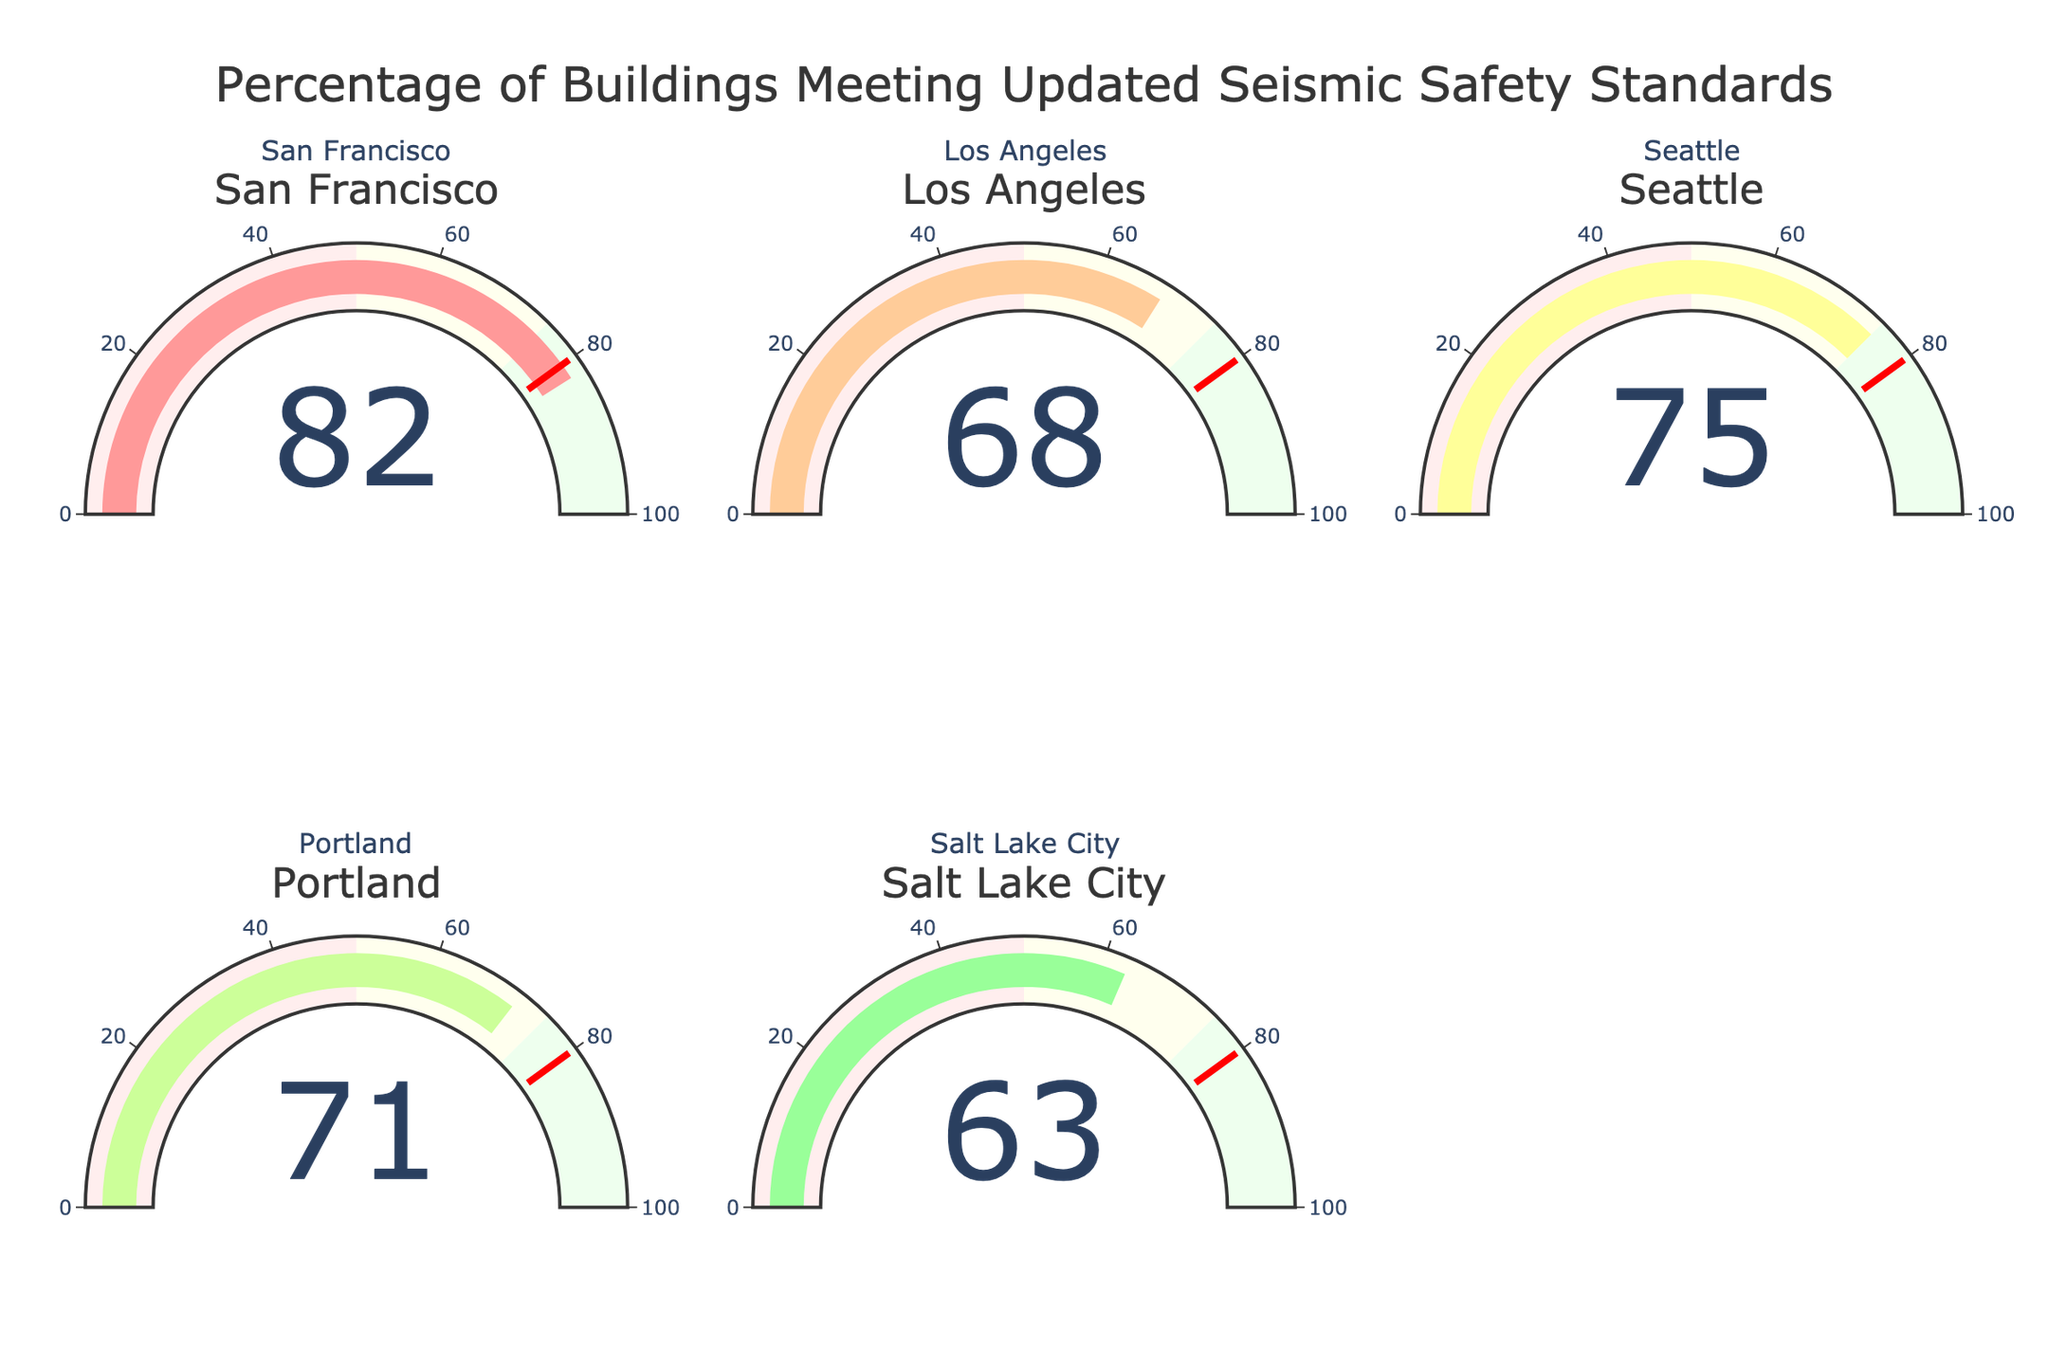What's the title of the chart? The title of the chart is displayed at the top center and reads "Percentage of Buildings Meeting Updated Seismic Safety Standards."
Answer: Percentage of Buildings Meeting Updated Seismic Safety Standards How many cities are represented in the chart? The chart has a total of 5 gauges, each representing a different city. This information can be observed by counting the number of individual gauge charts.
Answer: 5 Which city has the highest percentage of buildings meeting the updated seismic safety standards? The gauge showing the highest value is for San Francisco, which has 82%.
Answer: San Francisco Which city has the lowest percentage of buildings meeting the updated seismic safety standards? The gauge with the lowest value shows Salt Lake City with 63%.
Answer: Salt Lake City What's the average percentage of buildings meeting the updated seismic safety standards across all cities? Add the percentages for all cities (82 + 68 + 75 + 71 + 63) to get 359 and divide by the number of cities (5). The average is 359 / 5 = 71.8.
Answer: 71.8 What's the difference between the city with the highest percentage and the city with the lowest percentage? Subtract the lowest percentage (Salt Lake City, 63%) from the highest percentage (San Francisco, 82%), resulting in 82 - 63 = 19.
Answer: 19 Are there any cities that meet or exceed the threshold value of 80%? San Francisco has a value of 82%, which exceeds the threshold value of 80%. No other city meets or exceeds this value.
Answer: San Francisco What is the color of the gauge bar for the city with the highest percentage? The color of the gauge bar for San Francisco, which has the highest percentage, is custom and is '#FF9999' as it is placed first in the list of custom colors.
Answer: #FF9999 Which city has a percentage closest to the average across all cities? The calculated average is 71.8%. The city with the closest percentage to the average is Portland with 71%.
Answer: Portland How many cities have percentages above 70%? San Francisco (82%), Seattle (75%), and Portland (71%) all have percentages above 70%. Counting these, the total is 3 cities.
Answer: 3 